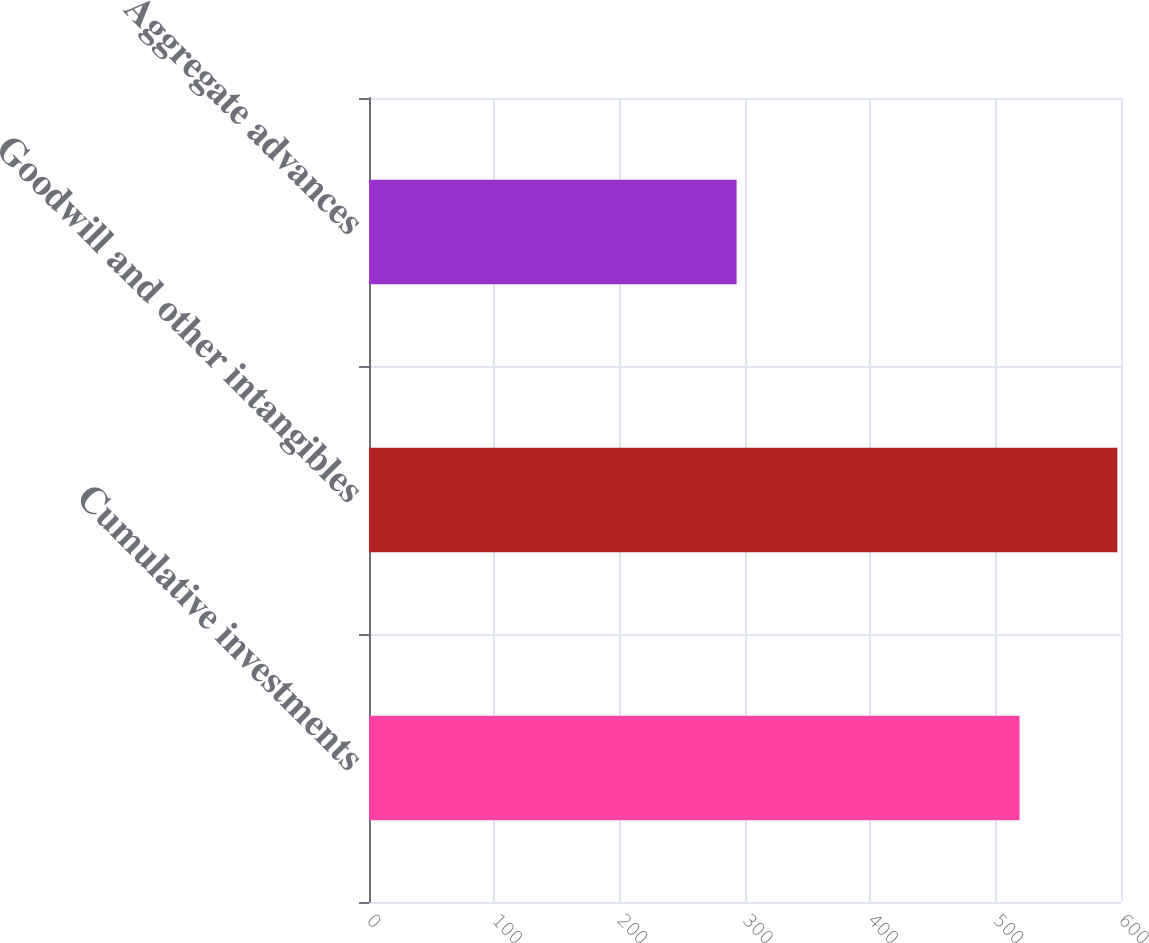<chart> <loc_0><loc_0><loc_500><loc_500><bar_chart><fcel>Cumulative investments<fcel>Goodwill and other intangibles<fcel>Aggregate advances<nl><fcel>519.1<fcel>597.1<fcel>293.3<nl></chart> 